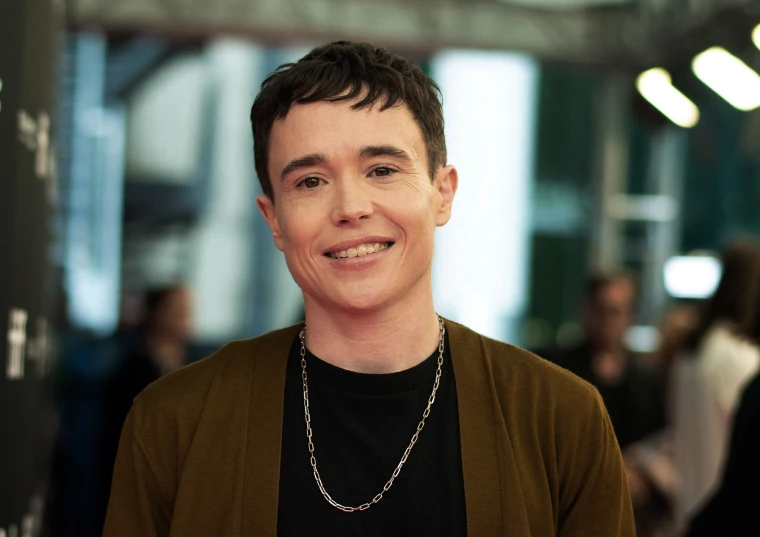What do you think is going on in this snapshot? In this image, a person is radiating candid joy. They stand against a blurred backdrop ensuring they are the focus. Wearing a stylish ensemble, featuring a black shirt under a brown blazer and a silver chain necklace adding a touch of sparkle to the outfit. Complementing their radiant smile directed towards the camera, their dark hair is styled short. The overall composition highlights their warm and inviting persona. 